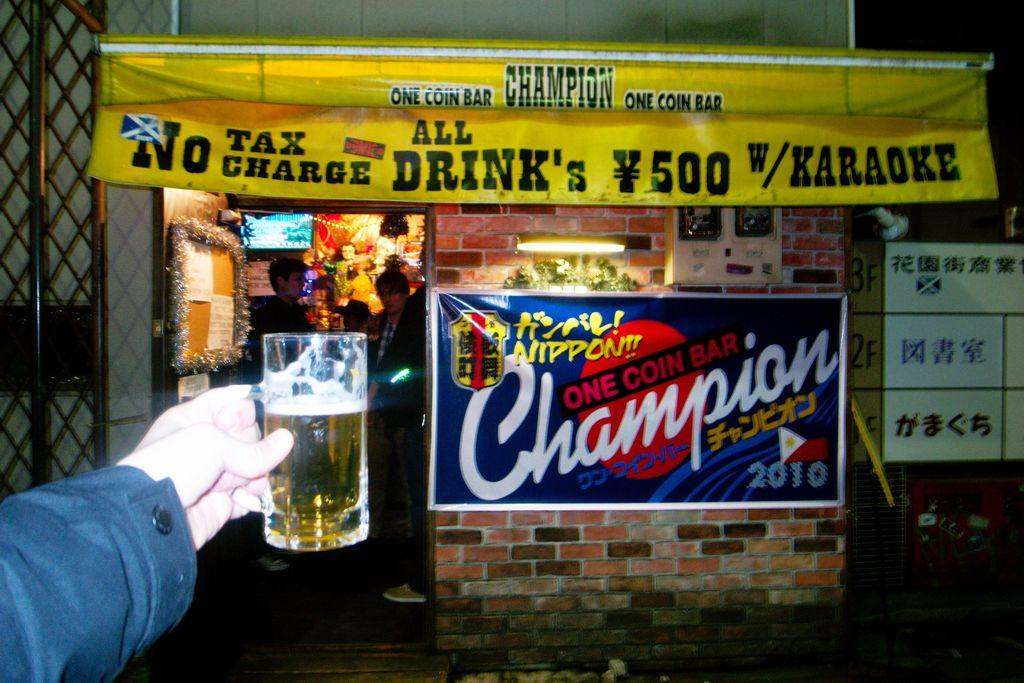Provide a one-sentence caption for the provided image. A person holding a beer in front of an All drink's no tax charge sign. 